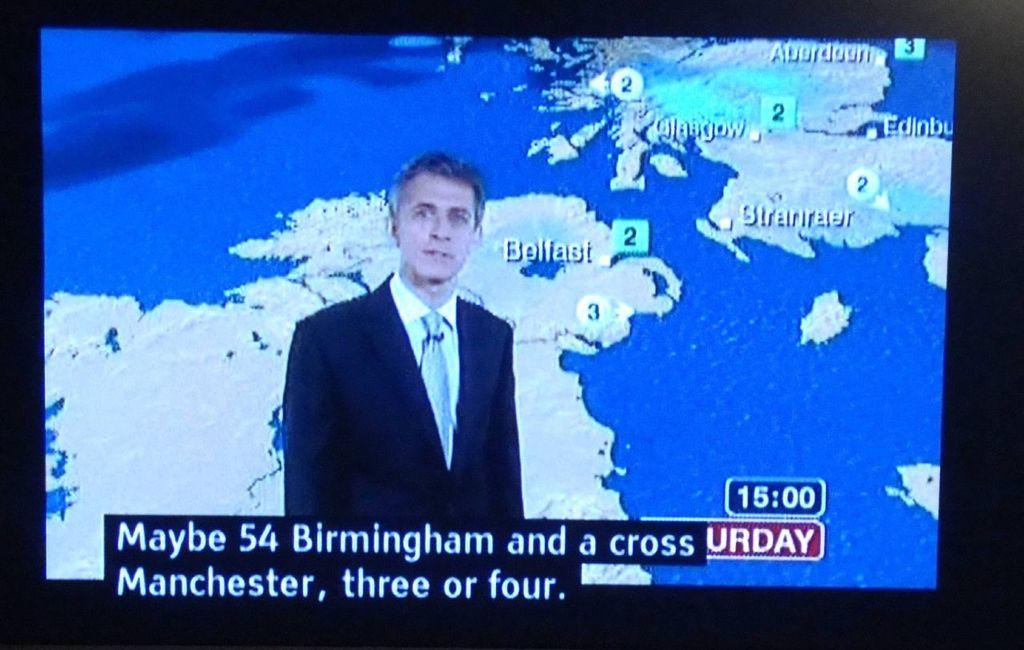What time is displayed in the right corner?
Your response must be concise. 15:00. 